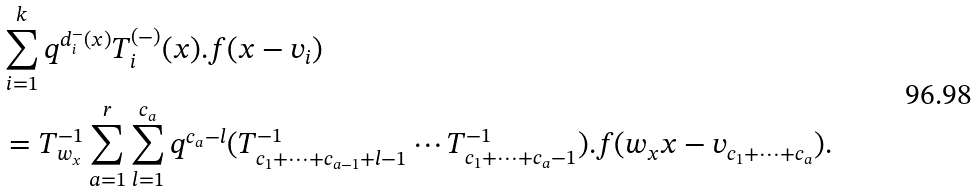Convert formula to latex. <formula><loc_0><loc_0><loc_500><loc_500>& \sum _ { i = 1 } ^ { k } q ^ { d _ { i } ^ { - } ( x ) } T _ { i } ^ { ( - ) } ( x ) . f ( x - v _ { i } ) \\ & = T _ { w _ { x } } ^ { - 1 } \sum _ { a = 1 } ^ { r } \sum _ { l = 1 } ^ { c _ { a } } q ^ { c _ { a } - l } ( T _ { c _ { 1 } + \cdots + c _ { a - 1 } + l - 1 } ^ { - 1 } \cdots T _ { c _ { 1 } + \cdots + c _ { a } - 1 } ^ { - 1 } ) . f ( w _ { x } x - v _ { c _ { 1 } + \cdots + c _ { a } } ) .</formula> 